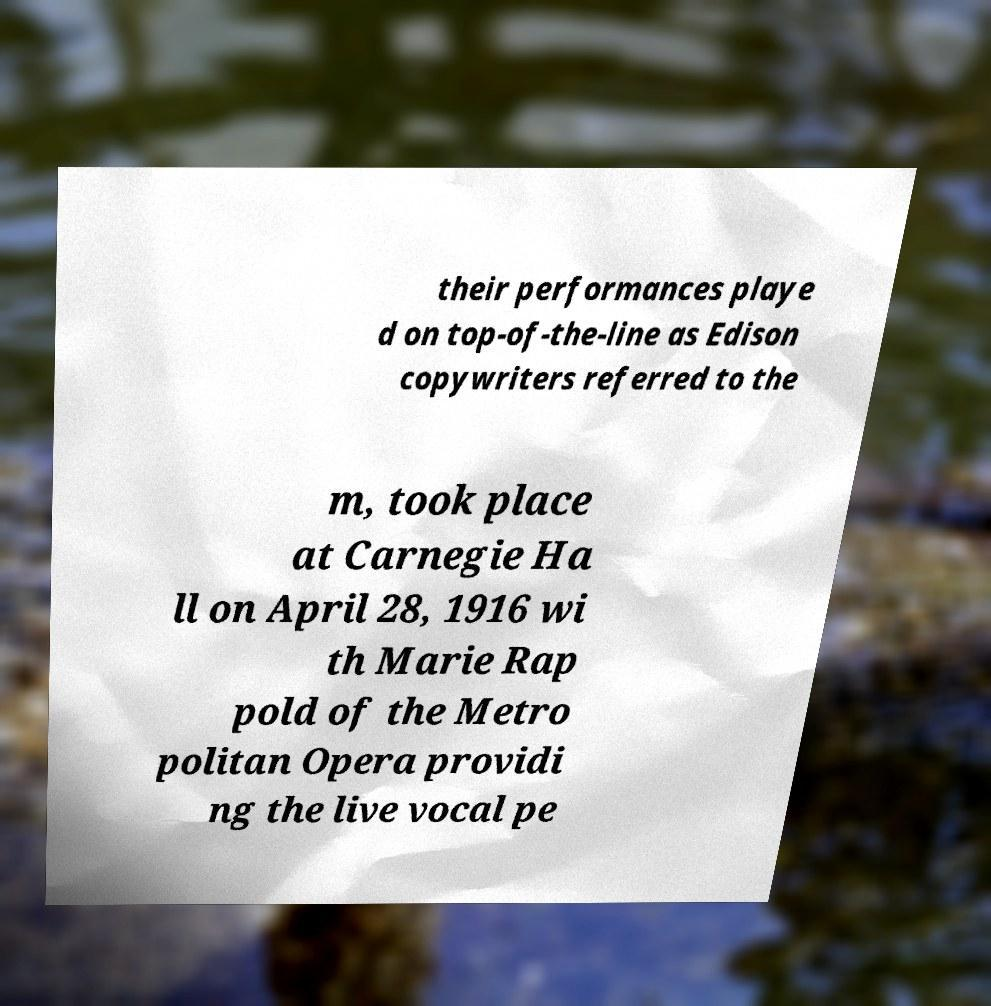There's text embedded in this image that I need extracted. Can you transcribe it verbatim? their performances playe d on top-of-the-line as Edison copywriters referred to the m, took place at Carnegie Ha ll on April 28, 1916 wi th Marie Rap pold of the Metro politan Opera providi ng the live vocal pe 